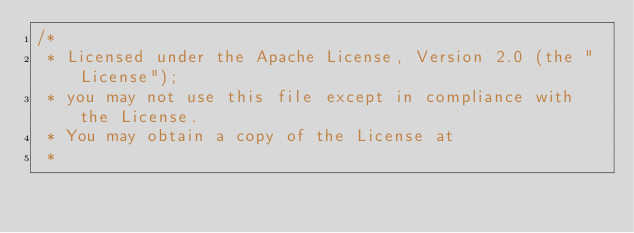<code> <loc_0><loc_0><loc_500><loc_500><_Java_>/*
 * Licensed under the Apache License, Version 2.0 (the "License");
 * you may not use this file except in compliance with the License.
 * You may obtain a copy of the License at
 *</code> 